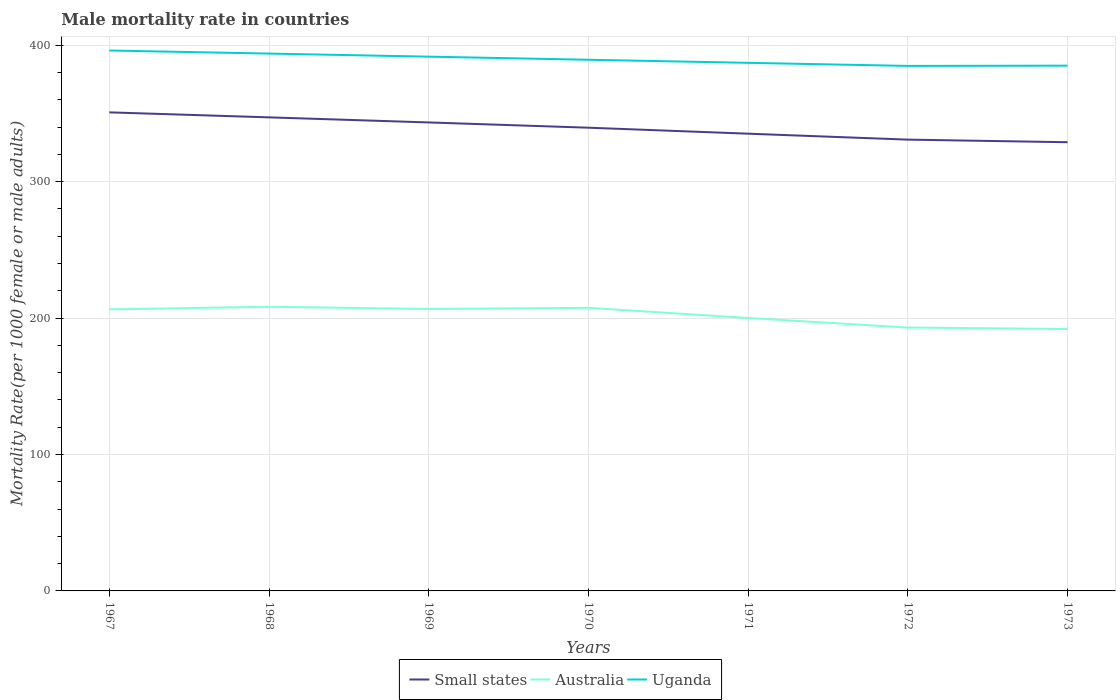How many different coloured lines are there?
Make the answer very short. 3. Is the number of lines equal to the number of legend labels?
Provide a succinct answer. Yes. Across all years, what is the maximum male mortality rate in Small states?
Offer a very short reply. 328.86. In which year was the male mortality rate in Small states maximum?
Your answer should be very brief. 1973. What is the total male mortality rate in Small states in the graph?
Your response must be concise. 8.74. What is the difference between the highest and the second highest male mortality rate in Small states?
Offer a very short reply. 21.88. Is the male mortality rate in Uganda strictly greater than the male mortality rate in Australia over the years?
Give a very brief answer. No. What is the difference between two consecutive major ticks on the Y-axis?
Keep it short and to the point. 100. How many legend labels are there?
Offer a terse response. 3. How are the legend labels stacked?
Ensure brevity in your answer.  Horizontal. What is the title of the graph?
Offer a terse response. Male mortality rate in countries. Does "Libya" appear as one of the legend labels in the graph?
Your answer should be very brief. No. What is the label or title of the Y-axis?
Make the answer very short. Mortality Rate(per 1000 female or male adults). What is the Mortality Rate(per 1000 female or male adults) in Small states in 1967?
Offer a terse response. 350.74. What is the Mortality Rate(per 1000 female or male adults) in Australia in 1967?
Give a very brief answer. 206.34. What is the Mortality Rate(per 1000 female or male adults) in Uganda in 1967?
Keep it short and to the point. 396.08. What is the Mortality Rate(per 1000 female or male adults) of Small states in 1968?
Offer a terse response. 347.07. What is the Mortality Rate(per 1000 female or male adults) of Australia in 1968?
Your response must be concise. 208.28. What is the Mortality Rate(per 1000 female or male adults) of Uganda in 1968?
Keep it short and to the point. 393.82. What is the Mortality Rate(per 1000 female or male adults) in Small states in 1969?
Your answer should be very brief. 343.35. What is the Mortality Rate(per 1000 female or male adults) of Australia in 1969?
Offer a very short reply. 206.64. What is the Mortality Rate(per 1000 female or male adults) in Uganda in 1969?
Keep it short and to the point. 391.56. What is the Mortality Rate(per 1000 female or male adults) of Small states in 1970?
Give a very brief answer. 339.5. What is the Mortality Rate(per 1000 female or male adults) in Australia in 1970?
Your answer should be compact. 207.49. What is the Mortality Rate(per 1000 female or male adults) of Uganda in 1970?
Offer a very short reply. 389.3. What is the Mortality Rate(per 1000 female or male adults) of Small states in 1971?
Offer a terse response. 335.11. What is the Mortality Rate(per 1000 female or male adults) of Australia in 1971?
Make the answer very short. 200.03. What is the Mortality Rate(per 1000 female or male adults) in Uganda in 1971?
Give a very brief answer. 387.04. What is the Mortality Rate(per 1000 female or male adults) in Small states in 1972?
Offer a very short reply. 330.76. What is the Mortality Rate(per 1000 female or male adults) in Australia in 1972?
Provide a short and direct response. 193.04. What is the Mortality Rate(per 1000 female or male adults) of Uganda in 1972?
Ensure brevity in your answer.  384.79. What is the Mortality Rate(per 1000 female or male adults) in Small states in 1973?
Your response must be concise. 328.86. What is the Mortality Rate(per 1000 female or male adults) in Australia in 1973?
Your response must be concise. 191.95. What is the Mortality Rate(per 1000 female or male adults) in Uganda in 1973?
Keep it short and to the point. 384.97. Across all years, what is the maximum Mortality Rate(per 1000 female or male adults) of Small states?
Your answer should be compact. 350.74. Across all years, what is the maximum Mortality Rate(per 1000 female or male adults) of Australia?
Give a very brief answer. 208.28. Across all years, what is the maximum Mortality Rate(per 1000 female or male adults) of Uganda?
Make the answer very short. 396.08. Across all years, what is the minimum Mortality Rate(per 1000 female or male adults) of Small states?
Provide a succinct answer. 328.86. Across all years, what is the minimum Mortality Rate(per 1000 female or male adults) in Australia?
Your response must be concise. 191.95. Across all years, what is the minimum Mortality Rate(per 1000 female or male adults) of Uganda?
Provide a short and direct response. 384.79. What is the total Mortality Rate(per 1000 female or male adults) in Small states in the graph?
Offer a very short reply. 2375.38. What is the total Mortality Rate(per 1000 female or male adults) of Australia in the graph?
Provide a short and direct response. 1413.76. What is the total Mortality Rate(per 1000 female or male adults) of Uganda in the graph?
Offer a very short reply. 2727.55. What is the difference between the Mortality Rate(per 1000 female or male adults) of Small states in 1967 and that in 1968?
Offer a very short reply. 3.67. What is the difference between the Mortality Rate(per 1000 female or male adults) of Australia in 1967 and that in 1968?
Make the answer very short. -1.94. What is the difference between the Mortality Rate(per 1000 female or male adults) of Uganda in 1967 and that in 1968?
Make the answer very short. 2.26. What is the difference between the Mortality Rate(per 1000 female or male adults) of Small states in 1967 and that in 1969?
Offer a very short reply. 7.39. What is the difference between the Mortality Rate(per 1000 female or male adults) in Australia in 1967 and that in 1969?
Ensure brevity in your answer.  -0.3. What is the difference between the Mortality Rate(per 1000 female or male adults) in Uganda in 1967 and that in 1969?
Provide a short and direct response. 4.52. What is the difference between the Mortality Rate(per 1000 female or male adults) of Small states in 1967 and that in 1970?
Give a very brief answer. 11.24. What is the difference between the Mortality Rate(per 1000 female or male adults) of Australia in 1967 and that in 1970?
Your answer should be very brief. -1.15. What is the difference between the Mortality Rate(per 1000 female or male adults) in Uganda in 1967 and that in 1970?
Your answer should be compact. 6.77. What is the difference between the Mortality Rate(per 1000 female or male adults) in Small states in 1967 and that in 1971?
Make the answer very short. 15.63. What is the difference between the Mortality Rate(per 1000 female or male adults) of Australia in 1967 and that in 1971?
Provide a succinct answer. 6.31. What is the difference between the Mortality Rate(per 1000 female or male adults) in Uganda in 1967 and that in 1971?
Provide a succinct answer. 9.03. What is the difference between the Mortality Rate(per 1000 female or male adults) in Small states in 1967 and that in 1972?
Provide a short and direct response. 19.98. What is the difference between the Mortality Rate(per 1000 female or male adults) of Australia in 1967 and that in 1972?
Offer a very short reply. 13.29. What is the difference between the Mortality Rate(per 1000 female or male adults) of Uganda in 1967 and that in 1972?
Give a very brief answer. 11.29. What is the difference between the Mortality Rate(per 1000 female or male adults) in Small states in 1967 and that in 1973?
Your answer should be compact. 21.88. What is the difference between the Mortality Rate(per 1000 female or male adults) in Australia in 1967 and that in 1973?
Your answer should be compact. 14.38. What is the difference between the Mortality Rate(per 1000 female or male adults) in Uganda in 1967 and that in 1973?
Your response must be concise. 11.11. What is the difference between the Mortality Rate(per 1000 female or male adults) of Small states in 1968 and that in 1969?
Offer a terse response. 3.72. What is the difference between the Mortality Rate(per 1000 female or male adults) in Australia in 1968 and that in 1969?
Make the answer very short. 1.64. What is the difference between the Mortality Rate(per 1000 female or male adults) of Uganda in 1968 and that in 1969?
Offer a very short reply. 2.26. What is the difference between the Mortality Rate(per 1000 female or male adults) in Small states in 1968 and that in 1970?
Your response must be concise. 7.57. What is the difference between the Mortality Rate(per 1000 female or male adults) of Australia in 1968 and that in 1970?
Offer a very short reply. 0.79. What is the difference between the Mortality Rate(per 1000 female or male adults) of Uganda in 1968 and that in 1970?
Provide a succinct answer. 4.52. What is the difference between the Mortality Rate(per 1000 female or male adults) of Small states in 1968 and that in 1971?
Give a very brief answer. 11.96. What is the difference between the Mortality Rate(per 1000 female or male adults) in Australia in 1968 and that in 1971?
Provide a succinct answer. 8.25. What is the difference between the Mortality Rate(per 1000 female or male adults) of Uganda in 1968 and that in 1971?
Offer a very short reply. 6.77. What is the difference between the Mortality Rate(per 1000 female or male adults) in Small states in 1968 and that in 1972?
Give a very brief answer. 16.32. What is the difference between the Mortality Rate(per 1000 female or male adults) of Australia in 1968 and that in 1972?
Provide a short and direct response. 15.23. What is the difference between the Mortality Rate(per 1000 female or male adults) in Uganda in 1968 and that in 1972?
Make the answer very short. 9.03. What is the difference between the Mortality Rate(per 1000 female or male adults) of Small states in 1968 and that in 1973?
Your response must be concise. 18.21. What is the difference between the Mortality Rate(per 1000 female or male adults) in Australia in 1968 and that in 1973?
Offer a very short reply. 16.32. What is the difference between the Mortality Rate(per 1000 female or male adults) in Uganda in 1968 and that in 1973?
Give a very brief answer. 8.85. What is the difference between the Mortality Rate(per 1000 female or male adults) of Small states in 1969 and that in 1970?
Give a very brief answer. 3.85. What is the difference between the Mortality Rate(per 1000 female or male adults) of Australia in 1969 and that in 1970?
Your answer should be compact. -0.85. What is the difference between the Mortality Rate(per 1000 female or male adults) of Uganda in 1969 and that in 1970?
Keep it short and to the point. 2.26. What is the difference between the Mortality Rate(per 1000 female or male adults) in Small states in 1969 and that in 1971?
Provide a succinct answer. 8.24. What is the difference between the Mortality Rate(per 1000 female or male adults) in Australia in 1969 and that in 1971?
Ensure brevity in your answer.  6.61. What is the difference between the Mortality Rate(per 1000 female or male adults) of Uganda in 1969 and that in 1971?
Your response must be concise. 4.52. What is the difference between the Mortality Rate(per 1000 female or male adults) in Small states in 1969 and that in 1972?
Ensure brevity in your answer.  12.59. What is the difference between the Mortality Rate(per 1000 female or male adults) in Australia in 1969 and that in 1972?
Offer a terse response. 13.6. What is the difference between the Mortality Rate(per 1000 female or male adults) of Uganda in 1969 and that in 1972?
Give a very brief answer. 6.77. What is the difference between the Mortality Rate(per 1000 female or male adults) of Small states in 1969 and that in 1973?
Offer a terse response. 14.49. What is the difference between the Mortality Rate(per 1000 female or male adults) of Australia in 1969 and that in 1973?
Give a very brief answer. 14.69. What is the difference between the Mortality Rate(per 1000 female or male adults) of Uganda in 1969 and that in 1973?
Offer a terse response. 6.59. What is the difference between the Mortality Rate(per 1000 female or male adults) of Small states in 1970 and that in 1971?
Make the answer very short. 4.39. What is the difference between the Mortality Rate(per 1000 female or male adults) in Australia in 1970 and that in 1971?
Offer a terse response. 7.46. What is the difference between the Mortality Rate(per 1000 female or male adults) in Uganda in 1970 and that in 1971?
Make the answer very short. 2.26. What is the difference between the Mortality Rate(per 1000 female or male adults) in Small states in 1970 and that in 1972?
Keep it short and to the point. 8.74. What is the difference between the Mortality Rate(per 1000 female or male adults) of Australia in 1970 and that in 1972?
Provide a succinct answer. 14.44. What is the difference between the Mortality Rate(per 1000 female or male adults) of Uganda in 1970 and that in 1972?
Keep it short and to the point. 4.52. What is the difference between the Mortality Rate(per 1000 female or male adults) of Small states in 1970 and that in 1973?
Make the answer very short. 10.64. What is the difference between the Mortality Rate(per 1000 female or male adults) of Australia in 1970 and that in 1973?
Provide a succinct answer. 15.53. What is the difference between the Mortality Rate(per 1000 female or male adults) in Uganda in 1970 and that in 1973?
Keep it short and to the point. 4.33. What is the difference between the Mortality Rate(per 1000 female or male adults) in Small states in 1971 and that in 1972?
Keep it short and to the point. 4.35. What is the difference between the Mortality Rate(per 1000 female or male adults) of Australia in 1971 and that in 1972?
Offer a very short reply. 6.99. What is the difference between the Mortality Rate(per 1000 female or male adults) in Uganda in 1971 and that in 1972?
Provide a succinct answer. 2.26. What is the difference between the Mortality Rate(per 1000 female or male adults) in Small states in 1971 and that in 1973?
Keep it short and to the point. 6.25. What is the difference between the Mortality Rate(per 1000 female or male adults) in Australia in 1971 and that in 1973?
Your answer should be very brief. 8.07. What is the difference between the Mortality Rate(per 1000 female or male adults) of Uganda in 1971 and that in 1973?
Provide a short and direct response. 2.08. What is the difference between the Mortality Rate(per 1000 female or male adults) of Small states in 1972 and that in 1973?
Make the answer very short. 1.9. What is the difference between the Mortality Rate(per 1000 female or male adults) in Australia in 1972 and that in 1973?
Offer a very short reply. 1.09. What is the difference between the Mortality Rate(per 1000 female or male adults) of Uganda in 1972 and that in 1973?
Offer a terse response. -0.18. What is the difference between the Mortality Rate(per 1000 female or male adults) in Small states in 1967 and the Mortality Rate(per 1000 female or male adults) in Australia in 1968?
Your answer should be compact. 142.46. What is the difference between the Mortality Rate(per 1000 female or male adults) in Small states in 1967 and the Mortality Rate(per 1000 female or male adults) in Uganda in 1968?
Give a very brief answer. -43.08. What is the difference between the Mortality Rate(per 1000 female or male adults) in Australia in 1967 and the Mortality Rate(per 1000 female or male adults) in Uganda in 1968?
Ensure brevity in your answer.  -187.48. What is the difference between the Mortality Rate(per 1000 female or male adults) in Small states in 1967 and the Mortality Rate(per 1000 female or male adults) in Australia in 1969?
Your answer should be compact. 144.1. What is the difference between the Mortality Rate(per 1000 female or male adults) of Small states in 1967 and the Mortality Rate(per 1000 female or male adults) of Uganda in 1969?
Make the answer very short. -40.82. What is the difference between the Mortality Rate(per 1000 female or male adults) in Australia in 1967 and the Mortality Rate(per 1000 female or male adults) in Uganda in 1969?
Offer a very short reply. -185.22. What is the difference between the Mortality Rate(per 1000 female or male adults) in Small states in 1967 and the Mortality Rate(per 1000 female or male adults) in Australia in 1970?
Your answer should be very brief. 143.25. What is the difference between the Mortality Rate(per 1000 female or male adults) in Small states in 1967 and the Mortality Rate(per 1000 female or male adults) in Uganda in 1970?
Make the answer very short. -38.56. What is the difference between the Mortality Rate(per 1000 female or male adults) of Australia in 1967 and the Mortality Rate(per 1000 female or male adults) of Uganda in 1970?
Provide a succinct answer. -182.97. What is the difference between the Mortality Rate(per 1000 female or male adults) in Small states in 1967 and the Mortality Rate(per 1000 female or male adults) in Australia in 1971?
Offer a very short reply. 150.71. What is the difference between the Mortality Rate(per 1000 female or male adults) in Small states in 1967 and the Mortality Rate(per 1000 female or male adults) in Uganda in 1971?
Offer a terse response. -36.31. What is the difference between the Mortality Rate(per 1000 female or male adults) in Australia in 1967 and the Mortality Rate(per 1000 female or male adults) in Uganda in 1971?
Offer a terse response. -180.71. What is the difference between the Mortality Rate(per 1000 female or male adults) of Small states in 1967 and the Mortality Rate(per 1000 female or male adults) of Australia in 1972?
Provide a succinct answer. 157.7. What is the difference between the Mortality Rate(per 1000 female or male adults) in Small states in 1967 and the Mortality Rate(per 1000 female or male adults) in Uganda in 1972?
Give a very brief answer. -34.05. What is the difference between the Mortality Rate(per 1000 female or male adults) of Australia in 1967 and the Mortality Rate(per 1000 female or male adults) of Uganda in 1972?
Your answer should be compact. -178.45. What is the difference between the Mortality Rate(per 1000 female or male adults) in Small states in 1967 and the Mortality Rate(per 1000 female or male adults) in Australia in 1973?
Make the answer very short. 158.78. What is the difference between the Mortality Rate(per 1000 female or male adults) of Small states in 1967 and the Mortality Rate(per 1000 female or male adults) of Uganda in 1973?
Provide a short and direct response. -34.23. What is the difference between the Mortality Rate(per 1000 female or male adults) of Australia in 1967 and the Mortality Rate(per 1000 female or male adults) of Uganda in 1973?
Your answer should be very brief. -178.63. What is the difference between the Mortality Rate(per 1000 female or male adults) in Small states in 1968 and the Mortality Rate(per 1000 female or male adults) in Australia in 1969?
Ensure brevity in your answer.  140.43. What is the difference between the Mortality Rate(per 1000 female or male adults) of Small states in 1968 and the Mortality Rate(per 1000 female or male adults) of Uganda in 1969?
Provide a short and direct response. -44.49. What is the difference between the Mortality Rate(per 1000 female or male adults) in Australia in 1968 and the Mortality Rate(per 1000 female or male adults) in Uganda in 1969?
Provide a succinct answer. -183.28. What is the difference between the Mortality Rate(per 1000 female or male adults) of Small states in 1968 and the Mortality Rate(per 1000 female or male adults) of Australia in 1970?
Your response must be concise. 139.59. What is the difference between the Mortality Rate(per 1000 female or male adults) in Small states in 1968 and the Mortality Rate(per 1000 female or male adults) in Uganda in 1970?
Your response must be concise. -42.23. What is the difference between the Mortality Rate(per 1000 female or male adults) of Australia in 1968 and the Mortality Rate(per 1000 female or male adults) of Uganda in 1970?
Offer a terse response. -181.03. What is the difference between the Mortality Rate(per 1000 female or male adults) of Small states in 1968 and the Mortality Rate(per 1000 female or male adults) of Australia in 1971?
Give a very brief answer. 147.04. What is the difference between the Mortality Rate(per 1000 female or male adults) in Small states in 1968 and the Mortality Rate(per 1000 female or male adults) in Uganda in 1971?
Offer a very short reply. -39.97. What is the difference between the Mortality Rate(per 1000 female or male adults) of Australia in 1968 and the Mortality Rate(per 1000 female or male adults) of Uganda in 1971?
Ensure brevity in your answer.  -178.77. What is the difference between the Mortality Rate(per 1000 female or male adults) of Small states in 1968 and the Mortality Rate(per 1000 female or male adults) of Australia in 1972?
Give a very brief answer. 154.03. What is the difference between the Mortality Rate(per 1000 female or male adults) in Small states in 1968 and the Mortality Rate(per 1000 female or male adults) in Uganda in 1972?
Keep it short and to the point. -37.71. What is the difference between the Mortality Rate(per 1000 female or male adults) of Australia in 1968 and the Mortality Rate(per 1000 female or male adults) of Uganda in 1972?
Your answer should be very brief. -176.51. What is the difference between the Mortality Rate(per 1000 female or male adults) in Small states in 1968 and the Mortality Rate(per 1000 female or male adults) in Australia in 1973?
Ensure brevity in your answer.  155.12. What is the difference between the Mortality Rate(per 1000 female or male adults) in Small states in 1968 and the Mortality Rate(per 1000 female or male adults) in Uganda in 1973?
Provide a short and direct response. -37.9. What is the difference between the Mortality Rate(per 1000 female or male adults) of Australia in 1968 and the Mortality Rate(per 1000 female or male adults) of Uganda in 1973?
Give a very brief answer. -176.69. What is the difference between the Mortality Rate(per 1000 female or male adults) in Small states in 1969 and the Mortality Rate(per 1000 female or male adults) in Australia in 1970?
Your answer should be compact. 135.86. What is the difference between the Mortality Rate(per 1000 female or male adults) of Small states in 1969 and the Mortality Rate(per 1000 female or male adults) of Uganda in 1970?
Your answer should be very brief. -45.95. What is the difference between the Mortality Rate(per 1000 female or male adults) in Australia in 1969 and the Mortality Rate(per 1000 female or male adults) in Uganda in 1970?
Keep it short and to the point. -182.66. What is the difference between the Mortality Rate(per 1000 female or male adults) of Small states in 1969 and the Mortality Rate(per 1000 female or male adults) of Australia in 1971?
Make the answer very short. 143.32. What is the difference between the Mortality Rate(per 1000 female or male adults) in Small states in 1969 and the Mortality Rate(per 1000 female or male adults) in Uganda in 1971?
Ensure brevity in your answer.  -43.7. What is the difference between the Mortality Rate(per 1000 female or male adults) of Australia in 1969 and the Mortality Rate(per 1000 female or male adults) of Uganda in 1971?
Ensure brevity in your answer.  -180.41. What is the difference between the Mortality Rate(per 1000 female or male adults) of Small states in 1969 and the Mortality Rate(per 1000 female or male adults) of Australia in 1972?
Provide a succinct answer. 150.31. What is the difference between the Mortality Rate(per 1000 female or male adults) of Small states in 1969 and the Mortality Rate(per 1000 female or male adults) of Uganda in 1972?
Your response must be concise. -41.44. What is the difference between the Mortality Rate(per 1000 female or male adults) of Australia in 1969 and the Mortality Rate(per 1000 female or male adults) of Uganda in 1972?
Keep it short and to the point. -178.15. What is the difference between the Mortality Rate(per 1000 female or male adults) in Small states in 1969 and the Mortality Rate(per 1000 female or male adults) in Australia in 1973?
Provide a succinct answer. 151.4. What is the difference between the Mortality Rate(per 1000 female or male adults) in Small states in 1969 and the Mortality Rate(per 1000 female or male adults) in Uganda in 1973?
Your response must be concise. -41.62. What is the difference between the Mortality Rate(per 1000 female or male adults) in Australia in 1969 and the Mortality Rate(per 1000 female or male adults) in Uganda in 1973?
Provide a succinct answer. -178.33. What is the difference between the Mortality Rate(per 1000 female or male adults) of Small states in 1970 and the Mortality Rate(per 1000 female or male adults) of Australia in 1971?
Make the answer very short. 139.47. What is the difference between the Mortality Rate(per 1000 female or male adults) in Small states in 1970 and the Mortality Rate(per 1000 female or male adults) in Uganda in 1971?
Give a very brief answer. -47.54. What is the difference between the Mortality Rate(per 1000 female or male adults) in Australia in 1970 and the Mortality Rate(per 1000 female or male adults) in Uganda in 1971?
Ensure brevity in your answer.  -179.56. What is the difference between the Mortality Rate(per 1000 female or male adults) in Small states in 1970 and the Mortality Rate(per 1000 female or male adults) in Australia in 1972?
Your answer should be very brief. 146.46. What is the difference between the Mortality Rate(per 1000 female or male adults) in Small states in 1970 and the Mortality Rate(per 1000 female or male adults) in Uganda in 1972?
Your answer should be very brief. -45.29. What is the difference between the Mortality Rate(per 1000 female or male adults) of Australia in 1970 and the Mortality Rate(per 1000 female or male adults) of Uganda in 1972?
Make the answer very short. -177.3. What is the difference between the Mortality Rate(per 1000 female or male adults) of Small states in 1970 and the Mortality Rate(per 1000 female or male adults) of Australia in 1973?
Provide a succinct answer. 147.55. What is the difference between the Mortality Rate(per 1000 female or male adults) in Small states in 1970 and the Mortality Rate(per 1000 female or male adults) in Uganda in 1973?
Ensure brevity in your answer.  -45.47. What is the difference between the Mortality Rate(per 1000 female or male adults) in Australia in 1970 and the Mortality Rate(per 1000 female or male adults) in Uganda in 1973?
Your answer should be very brief. -177.48. What is the difference between the Mortality Rate(per 1000 female or male adults) of Small states in 1971 and the Mortality Rate(per 1000 female or male adults) of Australia in 1972?
Make the answer very short. 142.06. What is the difference between the Mortality Rate(per 1000 female or male adults) of Small states in 1971 and the Mortality Rate(per 1000 female or male adults) of Uganda in 1972?
Make the answer very short. -49.68. What is the difference between the Mortality Rate(per 1000 female or male adults) of Australia in 1971 and the Mortality Rate(per 1000 female or male adults) of Uganda in 1972?
Provide a short and direct response. -184.76. What is the difference between the Mortality Rate(per 1000 female or male adults) of Small states in 1971 and the Mortality Rate(per 1000 female or male adults) of Australia in 1973?
Make the answer very short. 143.15. What is the difference between the Mortality Rate(per 1000 female or male adults) in Small states in 1971 and the Mortality Rate(per 1000 female or male adults) in Uganda in 1973?
Keep it short and to the point. -49.86. What is the difference between the Mortality Rate(per 1000 female or male adults) of Australia in 1971 and the Mortality Rate(per 1000 female or male adults) of Uganda in 1973?
Your response must be concise. -184.94. What is the difference between the Mortality Rate(per 1000 female or male adults) of Small states in 1972 and the Mortality Rate(per 1000 female or male adults) of Australia in 1973?
Offer a very short reply. 138.8. What is the difference between the Mortality Rate(per 1000 female or male adults) in Small states in 1972 and the Mortality Rate(per 1000 female or male adults) in Uganda in 1973?
Keep it short and to the point. -54.21. What is the difference between the Mortality Rate(per 1000 female or male adults) in Australia in 1972 and the Mortality Rate(per 1000 female or male adults) in Uganda in 1973?
Offer a terse response. -191.93. What is the average Mortality Rate(per 1000 female or male adults) of Small states per year?
Keep it short and to the point. 339.34. What is the average Mortality Rate(per 1000 female or male adults) in Australia per year?
Provide a short and direct response. 201.97. What is the average Mortality Rate(per 1000 female or male adults) in Uganda per year?
Your response must be concise. 389.65. In the year 1967, what is the difference between the Mortality Rate(per 1000 female or male adults) in Small states and Mortality Rate(per 1000 female or male adults) in Australia?
Provide a short and direct response. 144.4. In the year 1967, what is the difference between the Mortality Rate(per 1000 female or male adults) in Small states and Mortality Rate(per 1000 female or male adults) in Uganda?
Provide a short and direct response. -45.34. In the year 1967, what is the difference between the Mortality Rate(per 1000 female or male adults) of Australia and Mortality Rate(per 1000 female or male adults) of Uganda?
Keep it short and to the point. -189.74. In the year 1968, what is the difference between the Mortality Rate(per 1000 female or male adults) of Small states and Mortality Rate(per 1000 female or male adults) of Australia?
Make the answer very short. 138.8. In the year 1968, what is the difference between the Mortality Rate(per 1000 female or male adults) in Small states and Mortality Rate(per 1000 female or male adults) in Uganda?
Keep it short and to the point. -46.75. In the year 1968, what is the difference between the Mortality Rate(per 1000 female or male adults) in Australia and Mortality Rate(per 1000 female or male adults) in Uganda?
Your answer should be compact. -185.54. In the year 1969, what is the difference between the Mortality Rate(per 1000 female or male adults) in Small states and Mortality Rate(per 1000 female or male adults) in Australia?
Ensure brevity in your answer.  136.71. In the year 1969, what is the difference between the Mortality Rate(per 1000 female or male adults) in Small states and Mortality Rate(per 1000 female or male adults) in Uganda?
Provide a succinct answer. -48.21. In the year 1969, what is the difference between the Mortality Rate(per 1000 female or male adults) in Australia and Mortality Rate(per 1000 female or male adults) in Uganda?
Your answer should be very brief. -184.92. In the year 1970, what is the difference between the Mortality Rate(per 1000 female or male adults) of Small states and Mortality Rate(per 1000 female or male adults) of Australia?
Offer a very short reply. 132.01. In the year 1970, what is the difference between the Mortality Rate(per 1000 female or male adults) of Small states and Mortality Rate(per 1000 female or male adults) of Uganda?
Offer a very short reply. -49.8. In the year 1970, what is the difference between the Mortality Rate(per 1000 female or male adults) in Australia and Mortality Rate(per 1000 female or male adults) in Uganda?
Your response must be concise. -181.82. In the year 1971, what is the difference between the Mortality Rate(per 1000 female or male adults) of Small states and Mortality Rate(per 1000 female or male adults) of Australia?
Offer a terse response. 135.08. In the year 1971, what is the difference between the Mortality Rate(per 1000 female or male adults) in Small states and Mortality Rate(per 1000 female or male adults) in Uganda?
Your answer should be very brief. -51.94. In the year 1971, what is the difference between the Mortality Rate(per 1000 female or male adults) of Australia and Mortality Rate(per 1000 female or male adults) of Uganda?
Your answer should be very brief. -187.02. In the year 1972, what is the difference between the Mortality Rate(per 1000 female or male adults) in Small states and Mortality Rate(per 1000 female or male adults) in Australia?
Offer a terse response. 137.71. In the year 1972, what is the difference between the Mortality Rate(per 1000 female or male adults) of Small states and Mortality Rate(per 1000 female or male adults) of Uganda?
Provide a succinct answer. -54.03. In the year 1972, what is the difference between the Mortality Rate(per 1000 female or male adults) in Australia and Mortality Rate(per 1000 female or male adults) in Uganda?
Provide a short and direct response. -191.74. In the year 1973, what is the difference between the Mortality Rate(per 1000 female or male adults) in Small states and Mortality Rate(per 1000 female or male adults) in Australia?
Provide a succinct answer. 136.91. In the year 1973, what is the difference between the Mortality Rate(per 1000 female or male adults) of Small states and Mortality Rate(per 1000 female or male adults) of Uganda?
Keep it short and to the point. -56.11. In the year 1973, what is the difference between the Mortality Rate(per 1000 female or male adults) of Australia and Mortality Rate(per 1000 female or male adults) of Uganda?
Give a very brief answer. -193.02. What is the ratio of the Mortality Rate(per 1000 female or male adults) of Small states in 1967 to that in 1968?
Provide a succinct answer. 1.01. What is the ratio of the Mortality Rate(per 1000 female or male adults) of Small states in 1967 to that in 1969?
Offer a terse response. 1.02. What is the ratio of the Mortality Rate(per 1000 female or male adults) of Australia in 1967 to that in 1969?
Ensure brevity in your answer.  1. What is the ratio of the Mortality Rate(per 1000 female or male adults) of Uganda in 1967 to that in 1969?
Your answer should be very brief. 1.01. What is the ratio of the Mortality Rate(per 1000 female or male adults) of Small states in 1967 to that in 1970?
Provide a short and direct response. 1.03. What is the ratio of the Mortality Rate(per 1000 female or male adults) of Australia in 1967 to that in 1970?
Give a very brief answer. 0.99. What is the ratio of the Mortality Rate(per 1000 female or male adults) of Uganda in 1967 to that in 1970?
Offer a very short reply. 1.02. What is the ratio of the Mortality Rate(per 1000 female or male adults) of Small states in 1967 to that in 1971?
Your answer should be compact. 1.05. What is the ratio of the Mortality Rate(per 1000 female or male adults) in Australia in 1967 to that in 1971?
Provide a succinct answer. 1.03. What is the ratio of the Mortality Rate(per 1000 female or male adults) of Uganda in 1967 to that in 1971?
Ensure brevity in your answer.  1.02. What is the ratio of the Mortality Rate(per 1000 female or male adults) in Small states in 1967 to that in 1972?
Your response must be concise. 1.06. What is the ratio of the Mortality Rate(per 1000 female or male adults) of Australia in 1967 to that in 1972?
Give a very brief answer. 1.07. What is the ratio of the Mortality Rate(per 1000 female or male adults) in Uganda in 1967 to that in 1972?
Provide a short and direct response. 1.03. What is the ratio of the Mortality Rate(per 1000 female or male adults) of Small states in 1967 to that in 1973?
Provide a short and direct response. 1.07. What is the ratio of the Mortality Rate(per 1000 female or male adults) in Australia in 1967 to that in 1973?
Ensure brevity in your answer.  1.07. What is the ratio of the Mortality Rate(per 1000 female or male adults) in Uganda in 1967 to that in 1973?
Offer a terse response. 1.03. What is the ratio of the Mortality Rate(per 1000 female or male adults) in Small states in 1968 to that in 1969?
Your response must be concise. 1.01. What is the ratio of the Mortality Rate(per 1000 female or male adults) in Australia in 1968 to that in 1969?
Make the answer very short. 1.01. What is the ratio of the Mortality Rate(per 1000 female or male adults) in Uganda in 1968 to that in 1969?
Your response must be concise. 1.01. What is the ratio of the Mortality Rate(per 1000 female or male adults) in Small states in 1968 to that in 1970?
Make the answer very short. 1.02. What is the ratio of the Mortality Rate(per 1000 female or male adults) of Uganda in 1968 to that in 1970?
Your answer should be compact. 1.01. What is the ratio of the Mortality Rate(per 1000 female or male adults) in Small states in 1968 to that in 1971?
Provide a succinct answer. 1.04. What is the ratio of the Mortality Rate(per 1000 female or male adults) in Australia in 1968 to that in 1971?
Keep it short and to the point. 1.04. What is the ratio of the Mortality Rate(per 1000 female or male adults) of Uganda in 1968 to that in 1971?
Offer a very short reply. 1.02. What is the ratio of the Mortality Rate(per 1000 female or male adults) of Small states in 1968 to that in 1972?
Your answer should be very brief. 1.05. What is the ratio of the Mortality Rate(per 1000 female or male adults) of Australia in 1968 to that in 1972?
Your response must be concise. 1.08. What is the ratio of the Mortality Rate(per 1000 female or male adults) in Uganda in 1968 to that in 1972?
Provide a short and direct response. 1.02. What is the ratio of the Mortality Rate(per 1000 female or male adults) of Small states in 1968 to that in 1973?
Keep it short and to the point. 1.06. What is the ratio of the Mortality Rate(per 1000 female or male adults) in Australia in 1968 to that in 1973?
Make the answer very short. 1.08. What is the ratio of the Mortality Rate(per 1000 female or male adults) of Small states in 1969 to that in 1970?
Give a very brief answer. 1.01. What is the ratio of the Mortality Rate(per 1000 female or male adults) of Australia in 1969 to that in 1970?
Provide a succinct answer. 1. What is the ratio of the Mortality Rate(per 1000 female or male adults) of Uganda in 1969 to that in 1970?
Provide a short and direct response. 1.01. What is the ratio of the Mortality Rate(per 1000 female or male adults) in Small states in 1969 to that in 1971?
Offer a terse response. 1.02. What is the ratio of the Mortality Rate(per 1000 female or male adults) in Australia in 1969 to that in 1971?
Your answer should be compact. 1.03. What is the ratio of the Mortality Rate(per 1000 female or male adults) of Uganda in 1969 to that in 1971?
Provide a short and direct response. 1.01. What is the ratio of the Mortality Rate(per 1000 female or male adults) of Small states in 1969 to that in 1972?
Offer a very short reply. 1.04. What is the ratio of the Mortality Rate(per 1000 female or male adults) in Australia in 1969 to that in 1972?
Make the answer very short. 1.07. What is the ratio of the Mortality Rate(per 1000 female or male adults) in Uganda in 1969 to that in 1972?
Offer a terse response. 1.02. What is the ratio of the Mortality Rate(per 1000 female or male adults) of Small states in 1969 to that in 1973?
Keep it short and to the point. 1.04. What is the ratio of the Mortality Rate(per 1000 female or male adults) of Australia in 1969 to that in 1973?
Provide a succinct answer. 1.08. What is the ratio of the Mortality Rate(per 1000 female or male adults) in Uganda in 1969 to that in 1973?
Give a very brief answer. 1.02. What is the ratio of the Mortality Rate(per 1000 female or male adults) in Small states in 1970 to that in 1971?
Offer a terse response. 1.01. What is the ratio of the Mortality Rate(per 1000 female or male adults) of Australia in 1970 to that in 1971?
Provide a succinct answer. 1.04. What is the ratio of the Mortality Rate(per 1000 female or male adults) of Uganda in 1970 to that in 1971?
Offer a terse response. 1.01. What is the ratio of the Mortality Rate(per 1000 female or male adults) in Small states in 1970 to that in 1972?
Provide a short and direct response. 1.03. What is the ratio of the Mortality Rate(per 1000 female or male adults) in Australia in 1970 to that in 1972?
Offer a terse response. 1.07. What is the ratio of the Mortality Rate(per 1000 female or male adults) of Uganda in 1970 to that in 1972?
Offer a terse response. 1.01. What is the ratio of the Mortality Rate(per 1000 female or male adults) in Small states in 1970 to that in 1973?
Your answer should be compact. 1.03. What is the ratio of the Mortality Rate(per 1000 female or male adults) of Australia in 1970 to that in 1973?
Your answer should be very brief. 1.08. What is the ratio of the Mortality Rate(per 1000 female or male adults) of Uganda in 1970 to that in 1973?
Provide a succinct answer. 1.01. What is the ratio of the Mortality Rate(per 1000 female or male adults) of Small states in 1971 to that in 1972?
Your response must be concise. 1.01. What is the ratio of the Mortality Rate(per 1000 female or male adults) in Australia in 1971 to that in 1972?
Make the answer very short. 1.04. What is the ratio of the Mortality Rate(per 1000 female or male adults) in Uganda in 1971 to that in 1972?
Provide a succinct answer. 1.01. What is the ratio of the Mortality Rate(per 1000 female or male adults) in Australia in 1971 to that in 1973?
Your answer should be very brief. 1.04. What is the ratio of the Mortality Rate(per 1000 female or male adults) in Uganda in 1971 to that in 1973?
Keep it short and to the point. 1.01. What is the ratio of the Mortality Rate(per 1000 female or male adults) of Small states in 1972 to that in 1973?
Offer a terse response. 1.01. What is the ratio of the Mortality Rate(per 1000 female or male adults) of Australia in 1972 to that in 1973?
Your answer should be very brief. 1.01. What is the difference between the highest and the second highest Mortality Rate(per 1000 female or male adults) of Small states?
Keep it short and to the point. 3.67. What is the difference between the highest and the second highest Mortality Rate(per 1000 female or male adults) of Australia?
Give a very brief answer. 0.79. What is the difference between the highest and the second highest Mortality Rate(per 1000 female or male adults) in Uganda?
Make the answer very short. 2.26. What is the difference between the highest and the lowest Mortality Rate(per 1000 female or male adults) in Small states?
Offer a terse response. 21.88. What is the difference between the highest and the lowest Mortality Rate(per 1000 female or male adults) of Australia?
Give a very brief answer. 16.32. What is the difference between the highest and the lowest Mortality Rate(per 1000 female or male adults) in Uganda?
Make the answer very short. 11.29. 